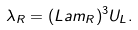Convert formula to latex. <formula><loc_0><loc_0><loc_500><loc_500>\lambda _ { R } = ( L a m _ { R } ) ^ { 3 } U _ { L } .</formula> 